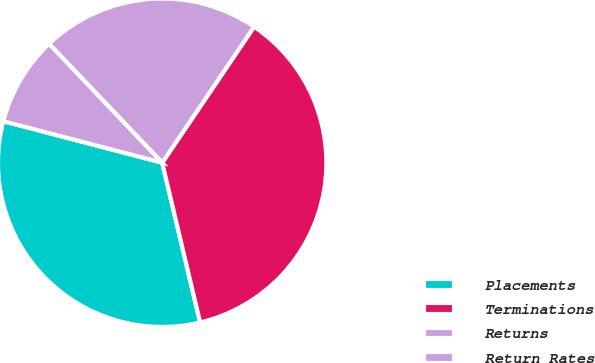<chart> <loc_0><loc_0><loc_500><loc_500><pie_chart><fcel>Placements<fcel>Terminations<fcel>Returns<fcel>Return Rates<nl><fcel>32.78%<fcel>36.83%<fcel>21.56%<fcel>8.83%<nl></chart> 